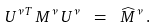Convert formula to latex. <formula><loc_0><loc_0><loc_500><loc_500>U ^ { \nu T } \, M ^ { \nu } \, U ^ { \nu } \ = \ \widehat { M } ^ { \nu } \, .</formula> 